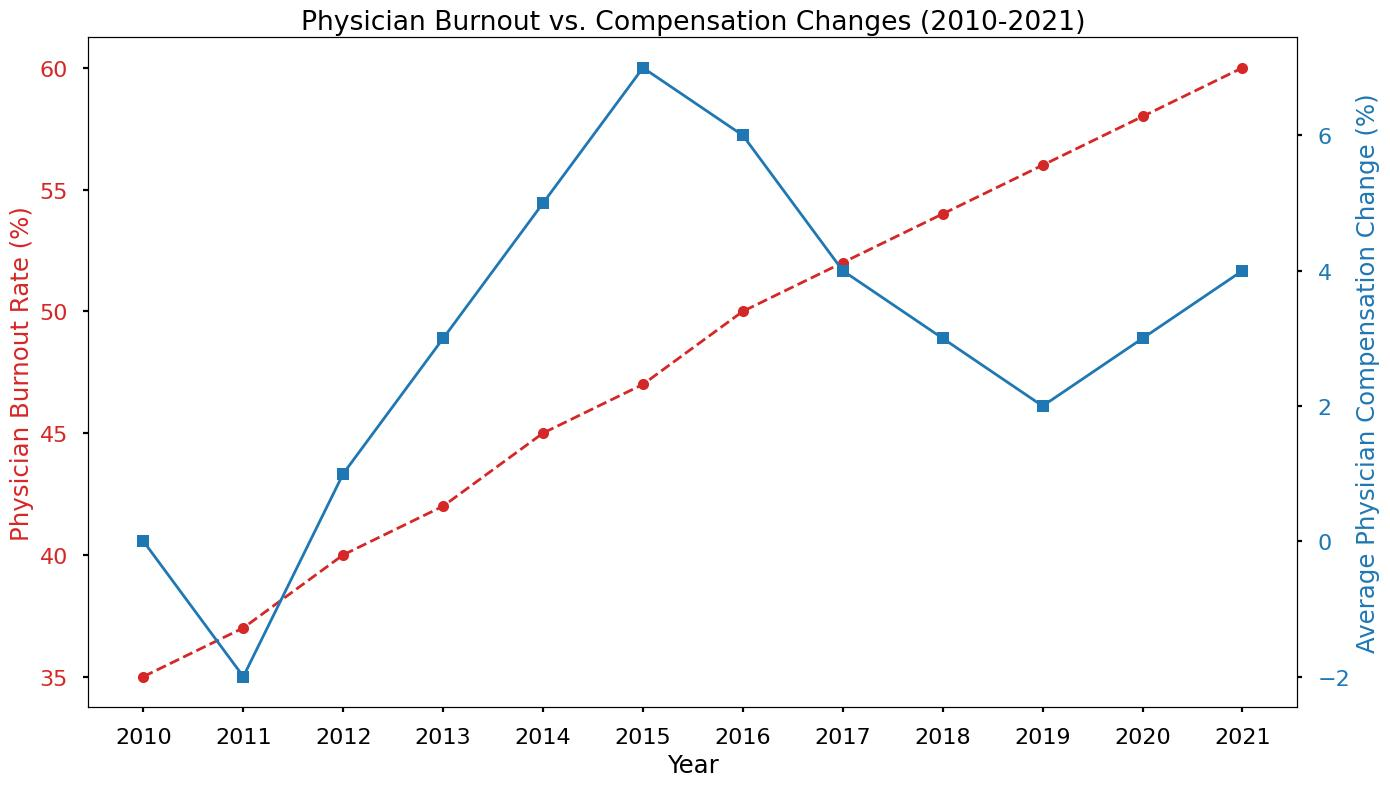What was the Physician Burnout Rate in 2013? Look at the red line representing burnout rates and find the point for 2013 on the x-axis, then check the corresponding y-axis value.
Answer: 42% What is the trend in Physician Burnout Rates from 2010 to 2021? Observe the red line that shows a consistent upward trend in burnout rates from 2010 (35%) to 2021 (60%).
Answer: Increasing How much did the Physician Burnout Rate increase from 2010 to 2021? Subtract the burnout rate in 2010 (35%) from the burnout rate in 2021 (60%).
Answer: 25% Which year had the highest Physician Burnout Rate and what was the rate? Identify the highest point on the red line and find the corresponding year and burnout rate.
Answer: 2021, 60% In which years did Physician Burnout Rates increase by the largest percentage? Calculate the year-over-year increases from the red line values and identify the largest jump.
Answer: 2015-2016 How did the Average Physician Compensation Change correlate with the Burnout Rate between 2014 and 2016? Compare the trends of the blue line (compensation changes) and the red line (burnout rates) between the years 2014 and 2016. Burnout increased from 45% to 50% while compensation increased from 5% to 6%.
Answer: Both increased What is the average Physician Burnout Rate from 2010 to 2021? Sum all the burnout rates from each year and divide by the number of years (12). (35% + 37% + 40% + 42% + 45% + 47% + 50% + 52% + 54% + 56% + 58% + 60%) / 12 = 48.75%
Answer: 48.75% Between 2016 and 2017, how did the Physician Burnout Rate change compared to the Average Physician Compensation Change? Check the differences in both rates: Burnout went from 50% to 52% and Compensation went from 6% to 4%, resulting in a 2% increase in burnout and a 2% decrease in compensation.
Answer: Burnout increased, Compensation decreased What was the Physician Burnout Rate when the Average Physician Compensation Change first became positive? Find the first year when the blue line is above 0% and check the corresponding burnout rate from the red line. The compensation was 1% in 2012 and the burnout rate was 40%.
Answer: 40% In which year(s) did the Average Physician Compensation Change become negative, and what were the values? Identify the years when the blue line is below 0% and note their values. This happened in 2011 with a change of -2%.
Answer: 2011, -2% 